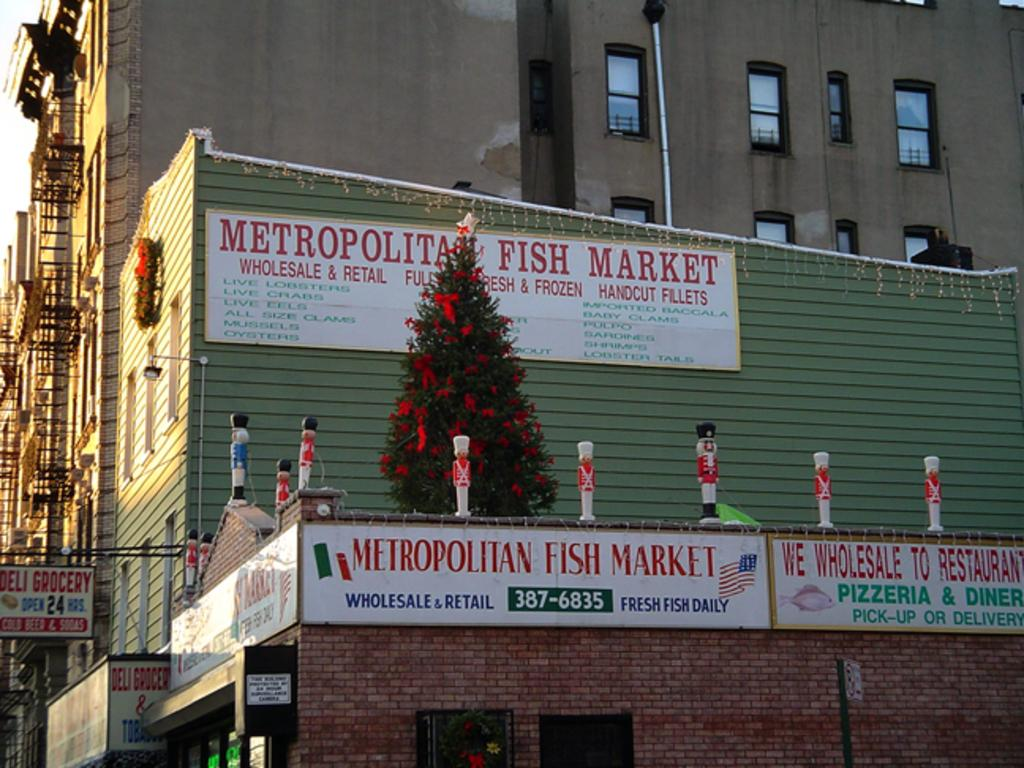What type of structures can be seen in the image? There are buildings in the image. What else is present on the buildings or walls in the image? There are posters in the image. What objects resemble toys and are visible in the image? There are objects that resemble toy poles in the image. What type of natural element is present in the image? There is a tree in the image. What type of celery can be seen growing near the buildings in the image? There is no celery present in the image; it features buildings, posters, toy poles, and a tree. What type of power source is visible in the image? There is no power source visible in the image; it only features buildings, posters, toy poles, and a tree. 